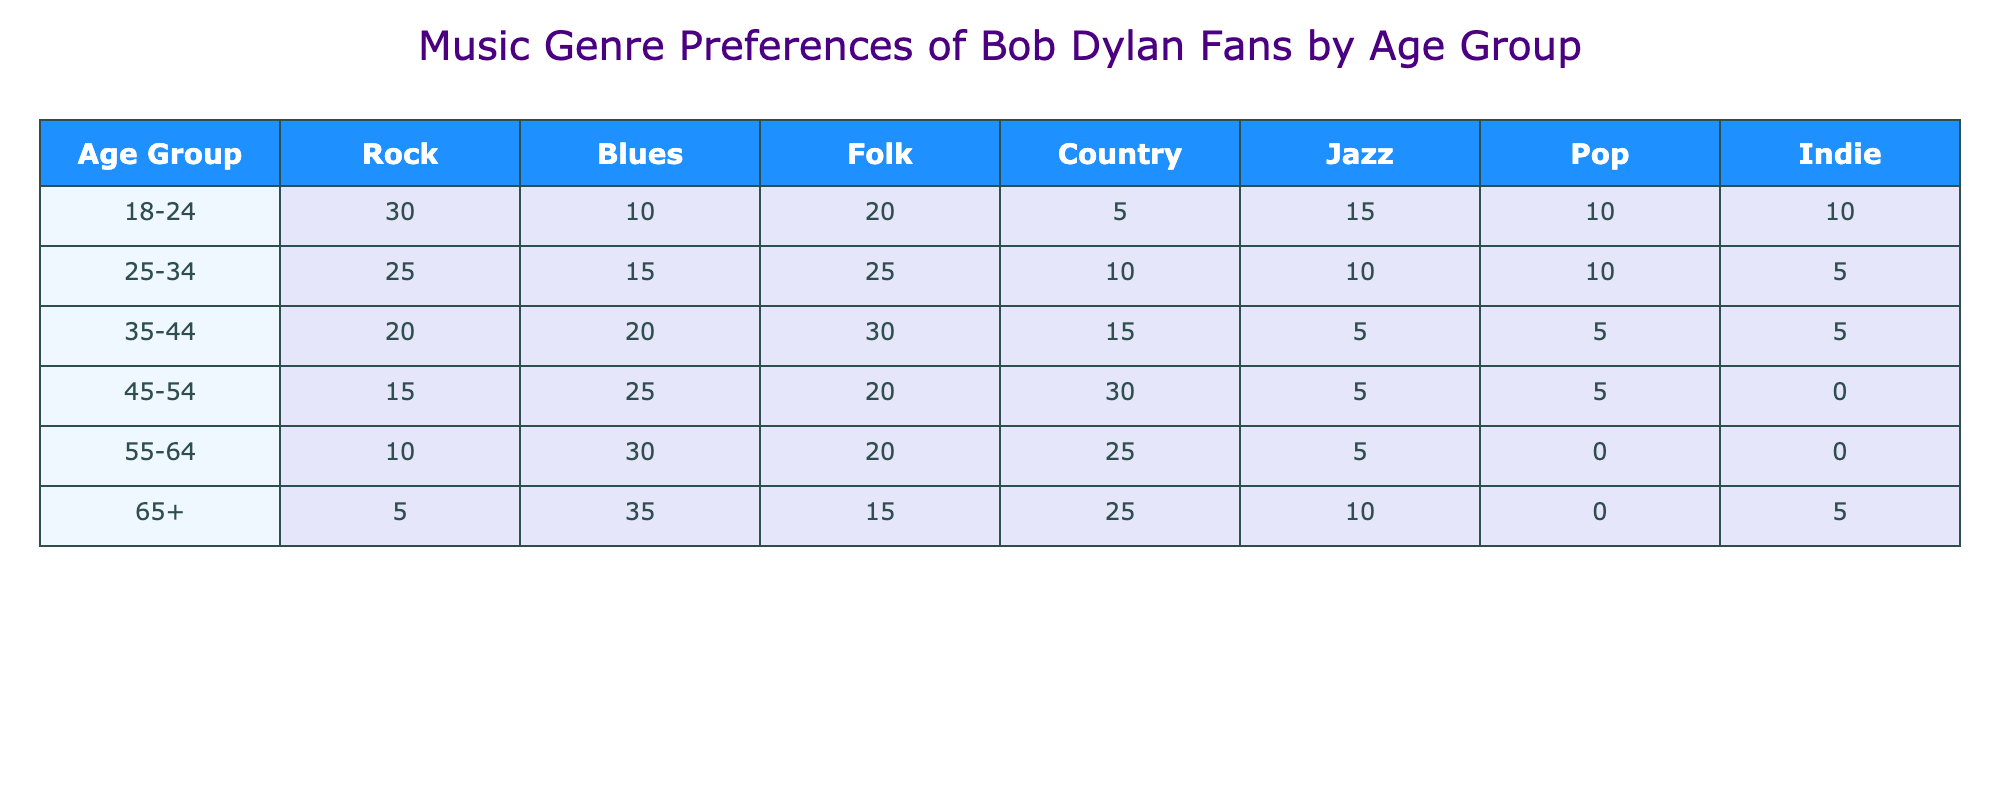What is the most popular music genre among the 18-24 age group? Looking at the 18-24 age group row, the highest number is 30 for the Rock genre.
Answer: Rock Which age group has the highest preference for Blues music? In the table, the Blues genre has the highest count in the 65+ age group with 35.
Answer: 65+ What is the total preference for Folk music across all age groups? To find the total preference for Folk music, we add the values for Folk from all age groups: 20 + 25 + 30 + 20 + 20 + 15 = 130.
Answer: 130 Is Jazz music more popular among the 55-64 age group than the 45-54 age group? The Jazz preference for the 55-64 age group is 5, while for the 45-54 age group it is also 5. So, they are equal; thus, the answer is no.
Answer: No What percentage of the 25-34 age group prefers Country music compared to the total preferences in that age group? The total preferences for the 25-34 age group are 25 + 15 + 25 + 10 + 10 + 10 + 5 = 100. The preference for Country music in that group is 10, so (10/100)*100 = 10%.
Answer: 10% Which genre is least popular in the 45-54 age group? Looking at the values for the 45-54 age group, the least popular genre is Indie, which has a count of 0.
Answer: Indie How does the preference for Rock music change from the 18-24 age group to the 65+ age group? The preference for Rock music in the 18-24 age group is 30, while in the 65+ age group it drops to 5. This indicates a decrease in preference.
Answer: Decrease What is the average preference for Country music across all age groups? The total preferences for Country music are 5 + 10 + 15 + 30 + 25 + 25 = 110. Since there are 6 age groups, the average is 110 / 6 ≈ 18.33.
Answer: 18.33 Which genre saw an increase in preference as age increased, when comparing the 25-34 age group to the 55-64 age group? When comparing, Blues showed an increase: 15 (25-34) to 30 (55-64), while Rock decreased from 25 to 10.
Answer: Blues 